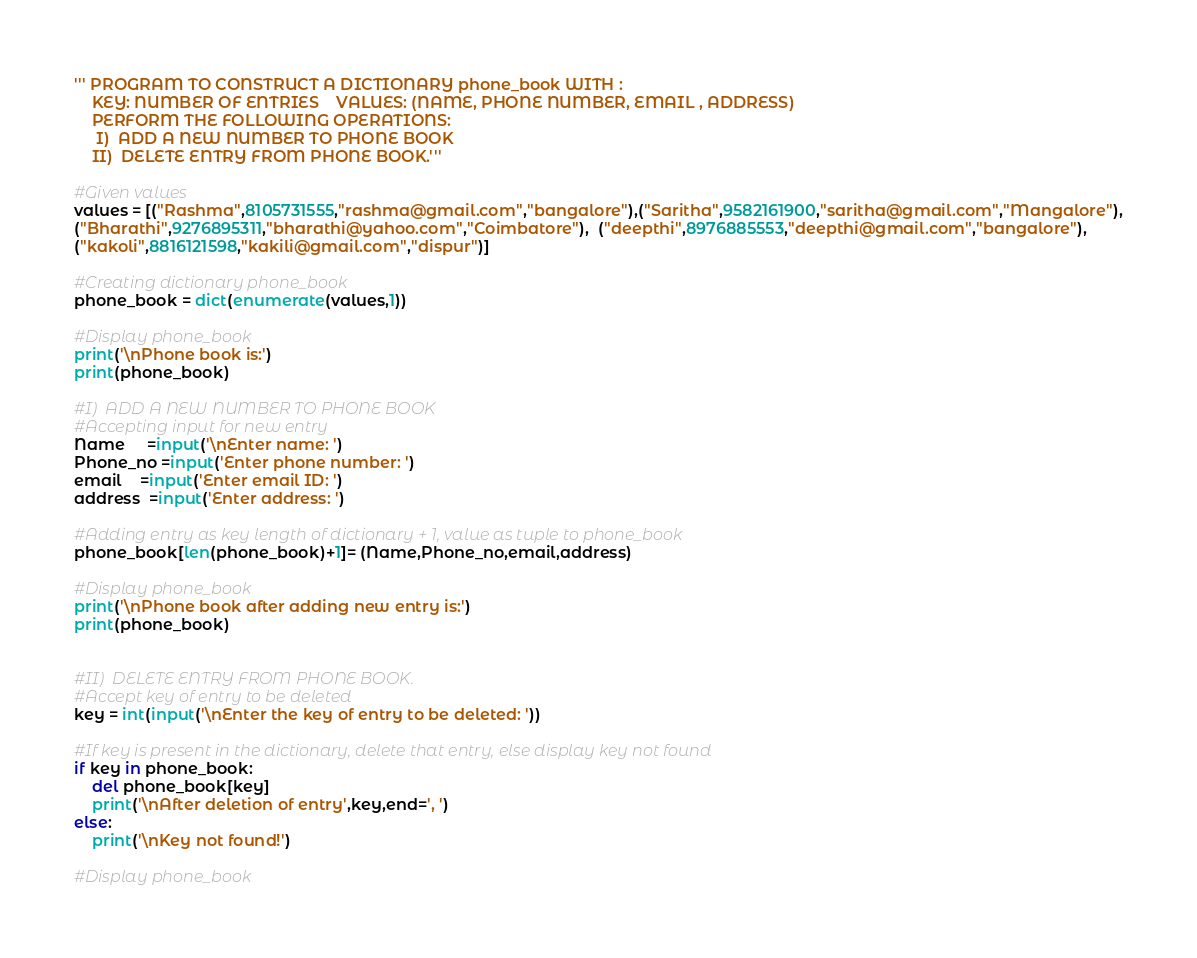Convert code to text. <code><loc_0><loc_0><loc_500><loc_500><_Python_>''' PROGRAM TO CONSTRUCT A DICTIONARY phone_book WITH :
    KEY: NUMBER OF ENTRIES    VALUES: (NAME, PHONE NUMBER, EMAIL , ADDRESS) 
    PERFORM THE FOLLOWING OPERATIONS:
     I)  ADD A NEW NUMBER TO PHONE BOOK
    II)  DELETE ENTRY FROM PHONE BOOK.'''

#Given values 
values = [("Rashma",8105731555,"rashma@gmail.com","bangalore"),("Saritha",9582161900,"saritha@gmail.com","Mangalore"),
("Bharathi",9276895311,"bharathi@yahoo.com","Coimbatore"),  ("deepthi",8976885553,"deepthi@gmail.com","bangalore"),
("kakoli",8816121598,"kakili@gmail.com","dispur")]

#Creating dictionary phone_book
phone_book = dict(enumerate(values,1))

#Display phone_book
print('\nPhone book is:')
print(phone_book)

#I)  ADD A NEW NUMBER TO PHONE BOOK
#Accepting input for new entry
Name     =input('\nEnter name: ')
Phone_no =input('Enter phone number: ')
email    =input('Enter email ID: ')
address  =input('Enter address: ')

#Adding entry as key length of dictionary + 1, value as tuple to phone_book
phone_book[len(phone_book)+1]= (Name,Phone_no,email,address)

#Display phone_book
print('\nPhone book after adding new entry is:')
print(phone_book)


#II)  DELETE ENTRY FROM PHONE BOOK.
#Accept key of entry to be deleted
key = int(input('\nEnter the key of entry to be deleted: '))

#If key is present in the dictionary, delete that entry, else display key not found
if key in phone_book:
    del phone_book[key]
    print('\nAfter deletion of entry',key,end=', ')
else:
    print('\nKey not found!')

#Display phone_book</code> 